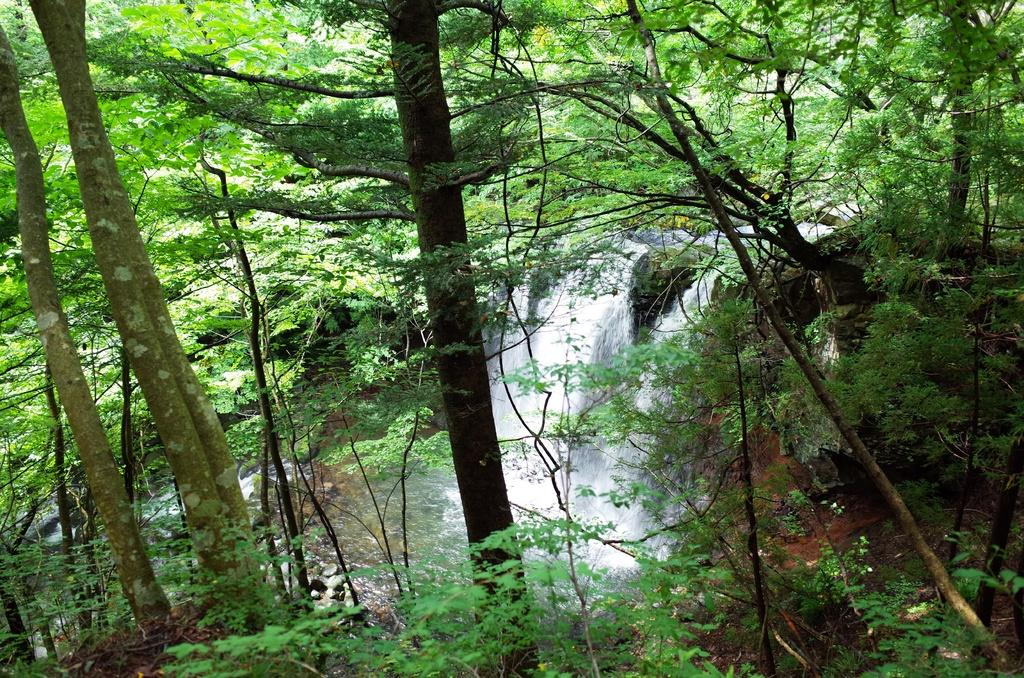What type of vegetation is visible in the image? There are trees in the image. What natural element can be seen besides the trees? There is water visible in the image. What type of geological formation is present in the image? There are rocks in the image. Can you see a hand reaching out of the water in the image? There is no hand visible in the image; it only features trees, water, and rocks. Is there anyone driving a vehicle in the image? There is no vehicle or person driving in the image. 